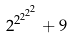Convert formula to latex. <formula><loc_0><loc_0><loc_500><loc_500>2 ^ { 2 ^ { 2 ^ { 2 ^ { 2 } } } } + 9</formula> 